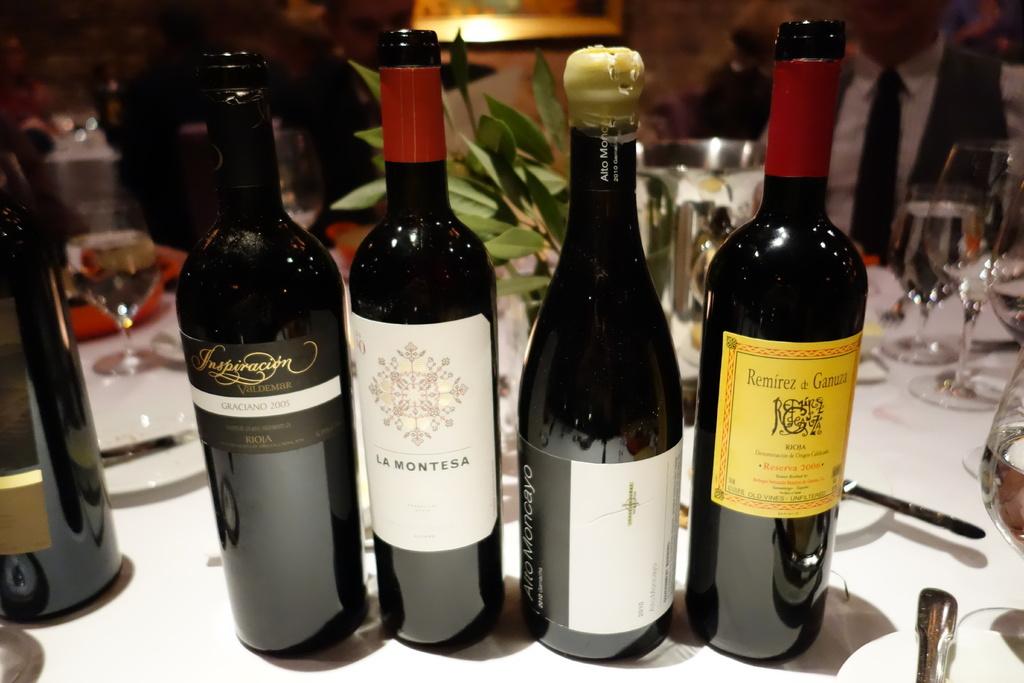What is the brand of wine in yellow?
Give a very brief answer. Remirez a ganuza. 